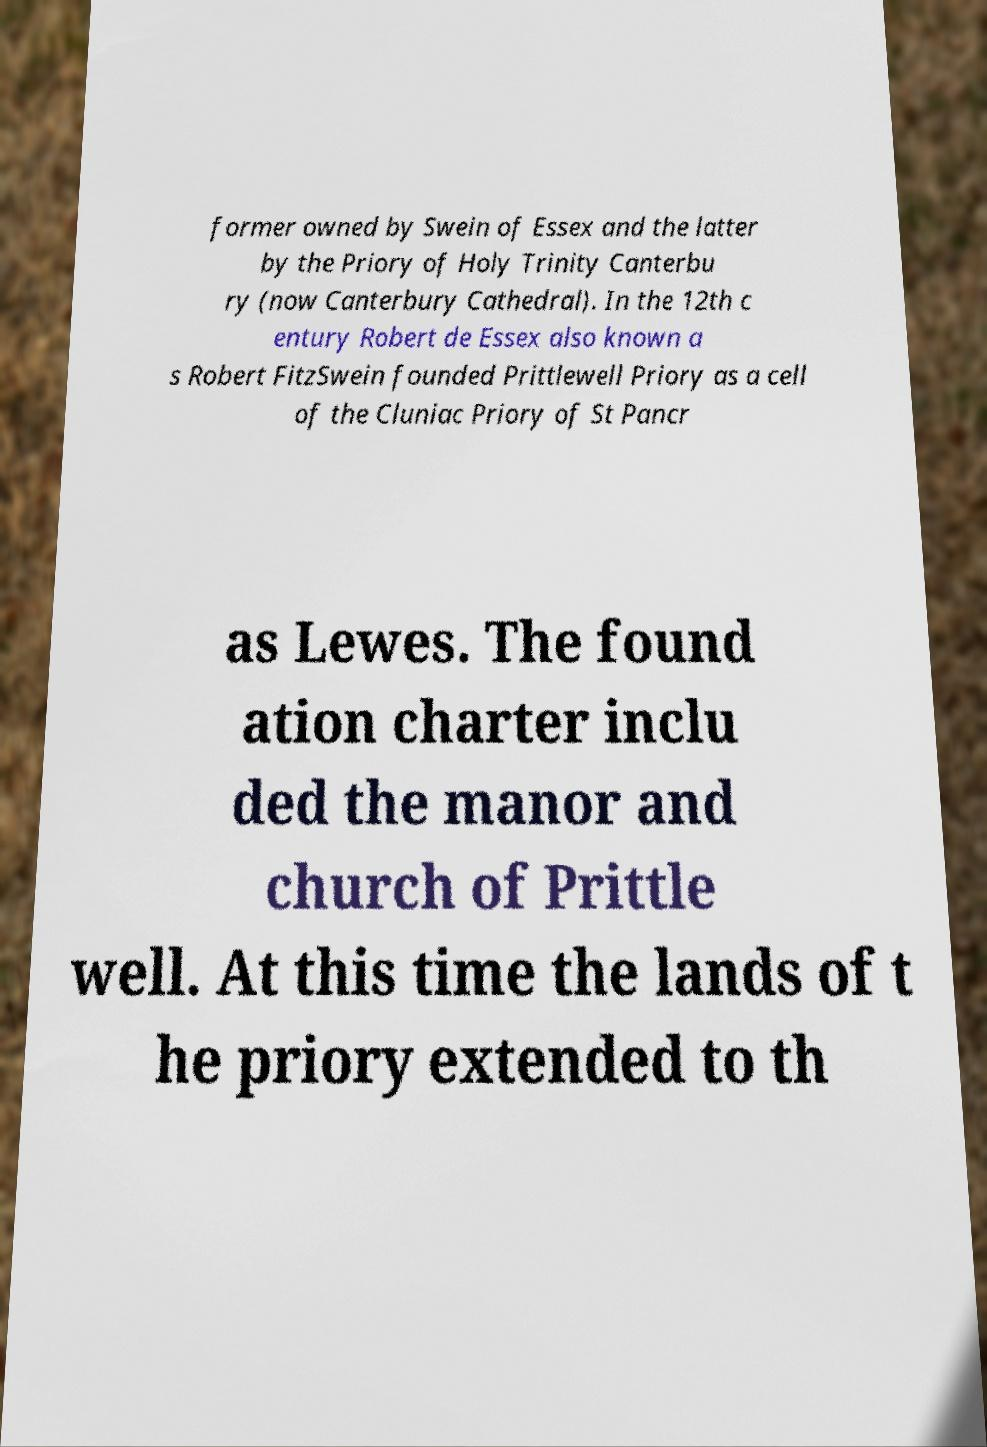Can you read and provide the text displayed in the image?This photo seems to have some interesting text. Can you extract and type it out for me? former owned by Swein of Essex and the latter by the Priory of Holy Trinity Canterbu ry (now Canterbury Cathedral). In the 12th c entury Robert de Essex also known a s Robert FitzSwein founded Prittlewell Priory as a cell of the Cluniac Priory of St Pancr as Lewes. The found ation charter inclu ded the manor and church of Prittle well. At this time the lands of t he priory extended to th 